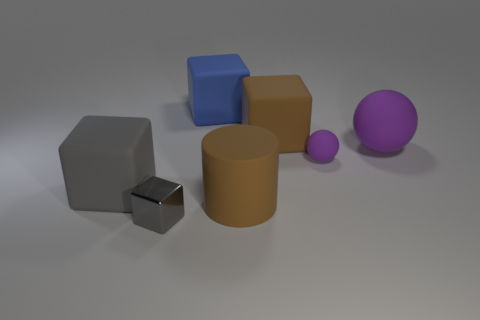Subtract 1 cubes. How many cubes are left? 3 Subtract all yellow blocks. Subtract all yellow balls. How many blocks are left? 4 Add 1 large yellow shiny spheres. How many objects exist? 8 Subtract all cubes. How many objects are left? 3 Add 5 brown balls. How many brown balls exist? 5 Subtract 0 red cylinders. How many objects are left? 7 Subtract all small red shiny balls. Subtract all big blue matte cubes. How many objects are left? 6 Add 2 small purple spheres. How many small purple spheres are left? 3 